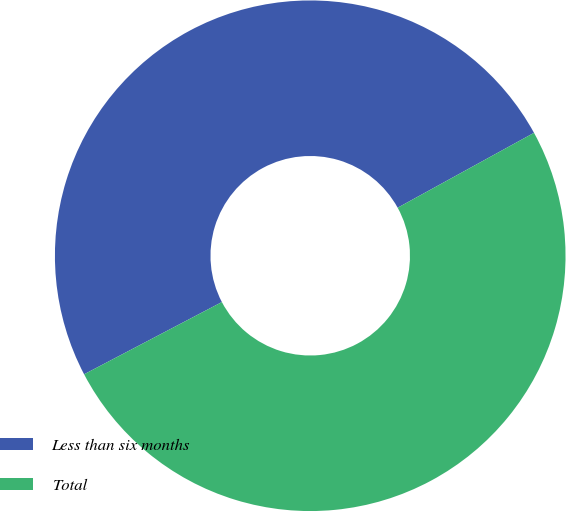<chart> <loc_0><loc_0><loc_500><loc_500><pie_chart><fcel>Less than six months<fcel>Total<nl><fcel>49.69%<fcel>50.31%<nl></chart> 